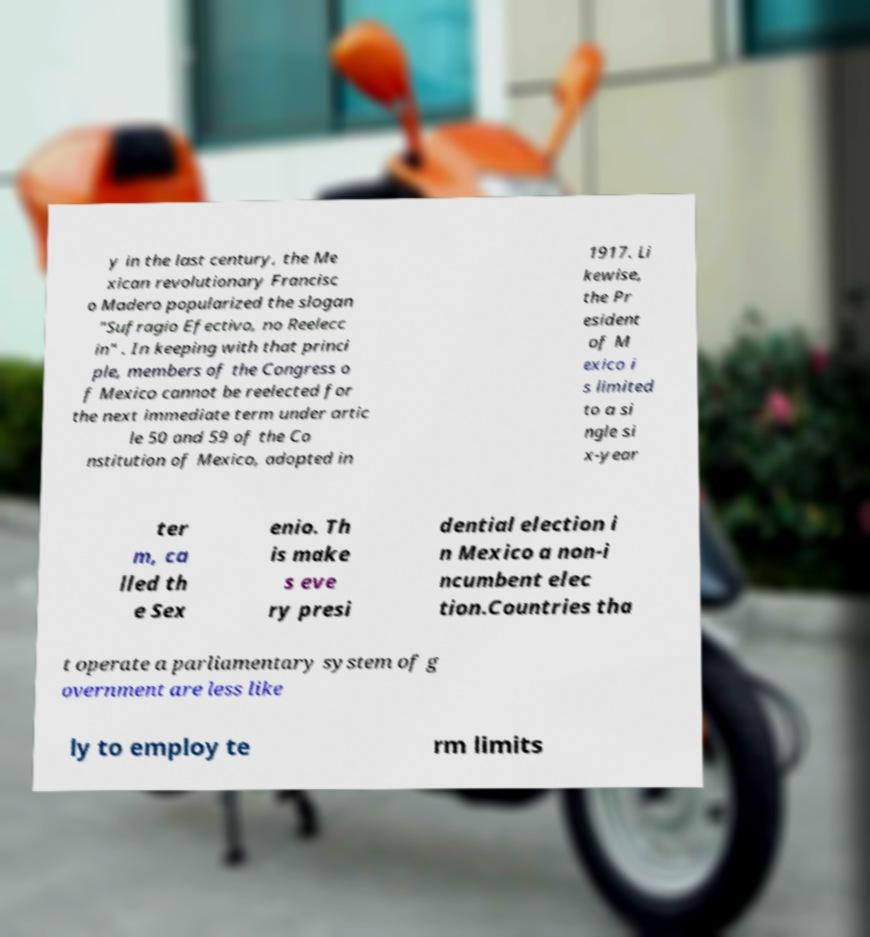What messages or text are displayed in this image? I need them in a readable, typed format. y in the last century, the Me xican revolutionary Francisc o Madero popularized the slogan "Sufragio Efectivo, no Reelecc in" . In keeping with that princi ple, members of the Congress o f Mexico cannot be reelected for the next immediate term under artic le 50 and 59 of the Co nstitution of Mexico, adopted in 1917. Li kewise, the Pr esident of M exico i s limited to a si ngle si x-year ter m, ca lled th e Sex enio. Th is make s eve ry presi dential election i n Mexico a non-i ncumbent elec tion.Countries tha t operate a parliamentary system of g overnment are less like ly to employ te rm limits 